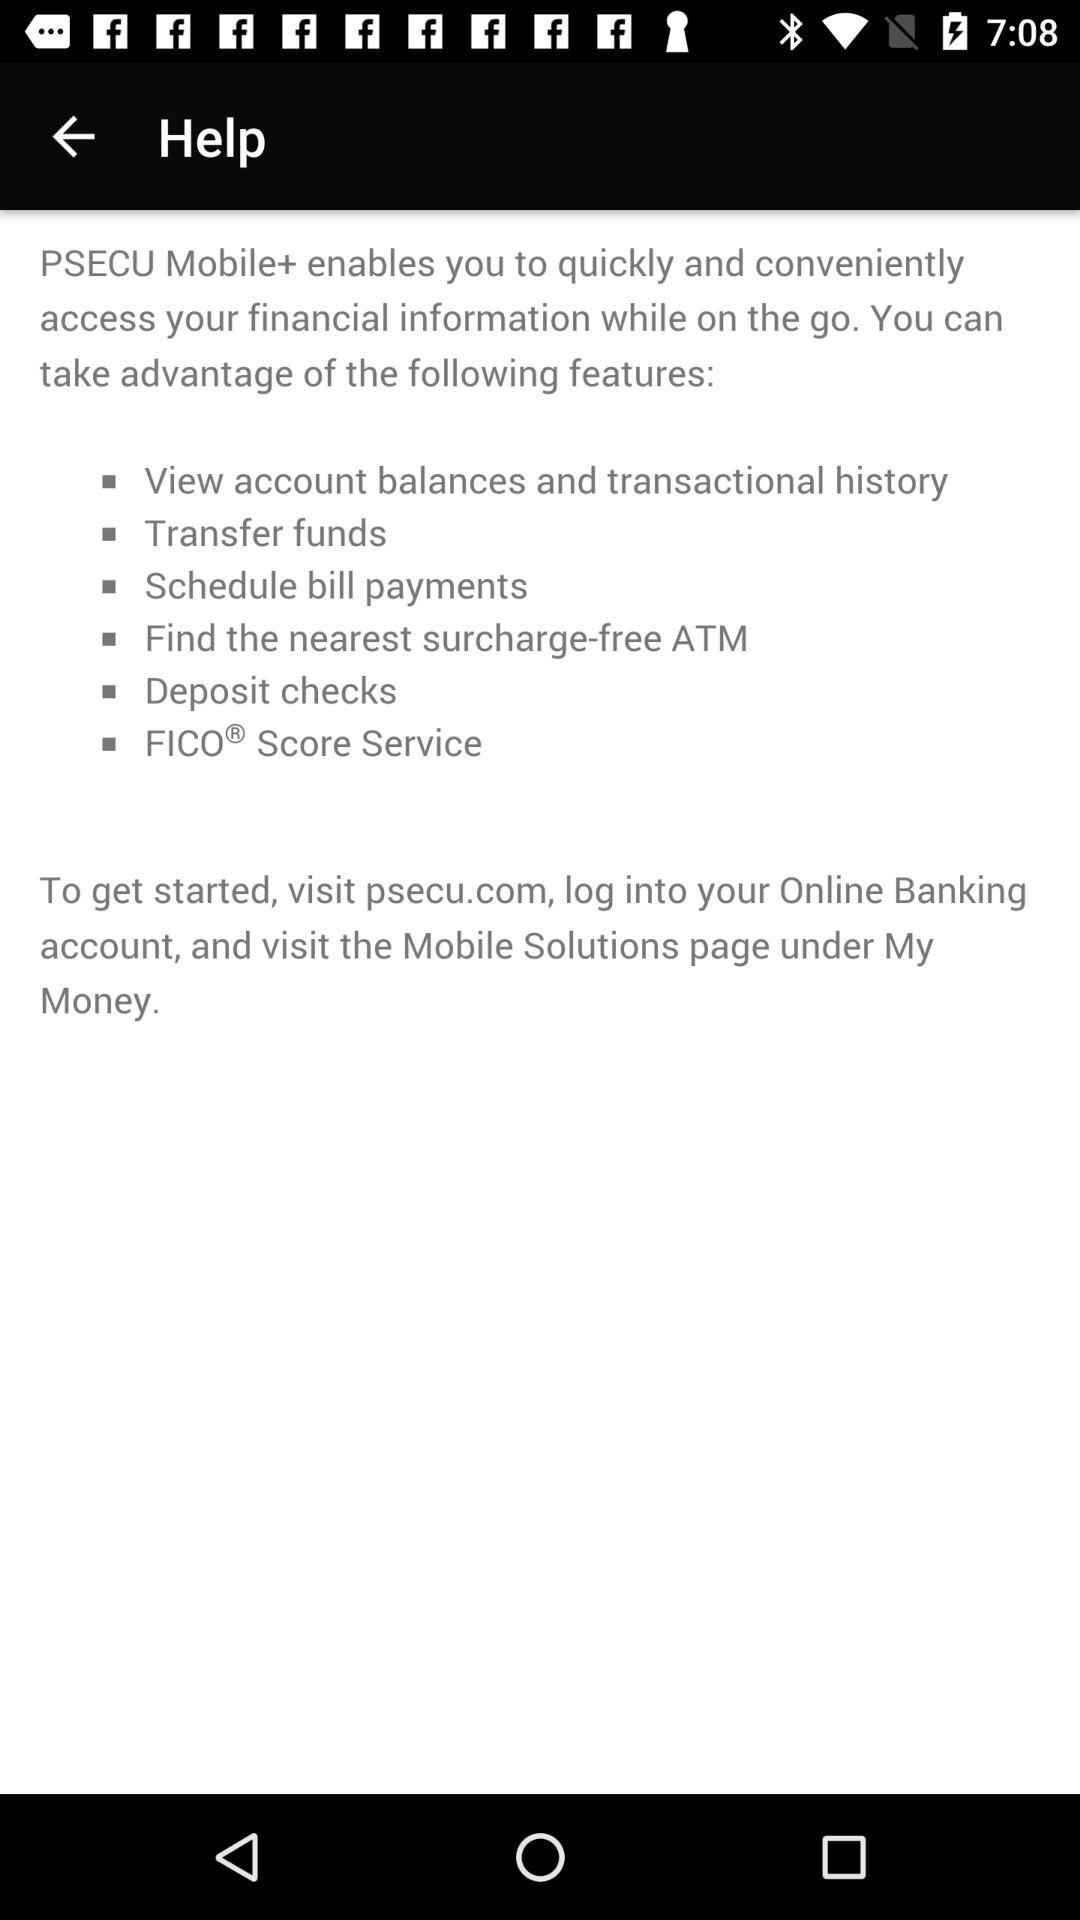What website should be visited to get started with PSECU? To get started with PSECU, the website that should be visited is psecu.com. 